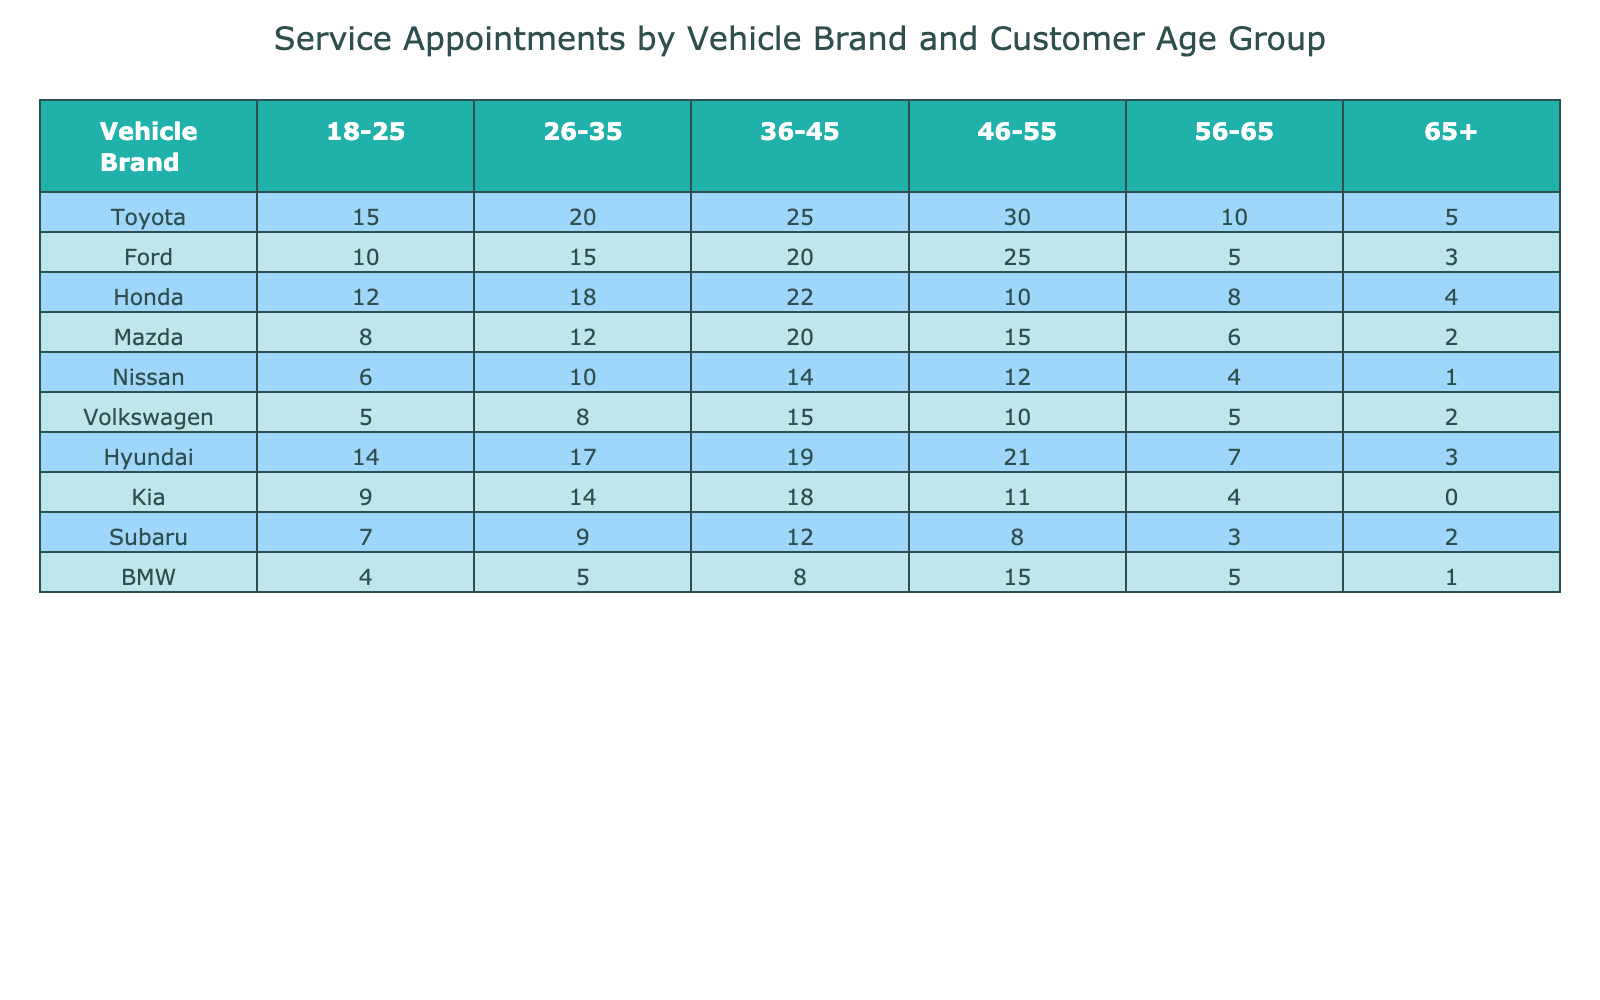What is the total number of service appointments for Toyota vehicles? To find the total number of service appointments for Toyota, we sum the values in the Toyota row: 15 + 20 + 25 + 30 + 10 + 5 = 105.
Answer: 105 Which age group has the highest number of service appointments for Ford vehicles? Looking at the Ford row, we can see the values by age group: 10, 15, 20, 25, 5, and 3. The highest value is 25, corresponding to the age group 46-55.
Answer: 46-55 How many service appointments were recorded for vehicles from all brands combined in the 36-45 age group? We add up the values from each brand for the 36-45 age group: 25 (Toyota) + 20 (Ford) + 22 (Honda) + 20 (Mazda) + 14 (Nissan) + 15 (Volkswagen) + 19 (Hyundai) + 18 (Kia) + 12 (Subaru) + 8 (BMW) =  180.
Answer: 180 Is the number of service appointments for Hyundai vehicles greater than the number for BMW vehicles across all age groups? Firstly, we find the total for Hyundai: 14 + 17 + 19 + 21 + 7 + 3 = 81. Next, for BMW: 4 + 5 + 8 + 15 + 5 + 1 = 38. Since 81 is greater than 38, the answer is yes.
Answer: Yes What is the average number of service appointments for Kia vehicles across all age groups? We sum the appointments for Kia: 9 + 14 + 18 + 11 + 4 + 0 = 56. There are 6 age groups, so we divide the total by 6: 56 / 6 = approximately 9.33.
Answer: Approximately 9.33 Which vehicle brand has the lowest total number of service appointments in the table? We calculate the totals for each brand: Toyota (105), Ford (73), Honda (74), Mazda (63), Nissan (47), Volkswagen (45), Hyundai (81), Kia (56), Subaru (41), and BMW (38). The lowest total is for BMW with 38 appointments.
Answer: BMW What is the difference in service appointments between the youngest (18-25) and the oldest (65+) age groups for all vehicle brands combined? We calculate the sum of service appointments for the 18-25 age group: 15 + 10 + 12 + 8 + 6 + 5 + 14 + 9 + 7 + 4 = 86. For the 65+ age group: 5 + 3 + 4 + 2 + 1 + 2 + 3 + 0 + 2 + 1 = 23. The difference is 86 - 23 = 63.
Answer: 63 How many service appointments does Honda have in the 46-55 age group? Referring to the Honda row, the value in the 46-55 age group is 10.
Answer: 10 